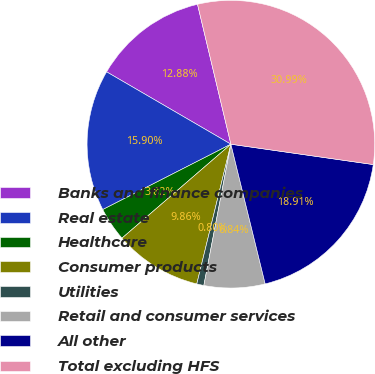Convert chart to OTSL. <chart><loc_0><loc_0><loc_500><loc_500><pie_chart><fcel>Banks and finance companies<fcel>Real estate<fcel>Healthcare<fcel>Consumer products<fcel>Utilities<fcel>Retail and consumer services<fcel>All other<fcel>Total excluding HFS<nl><fcel>12.88%<fcel>15.9%<fcel>3.82%<fcel>9.86%<fcel>0.8%<fcel>6.84%<fcel>18.91%<fcel>30.99%<nl></chart> 